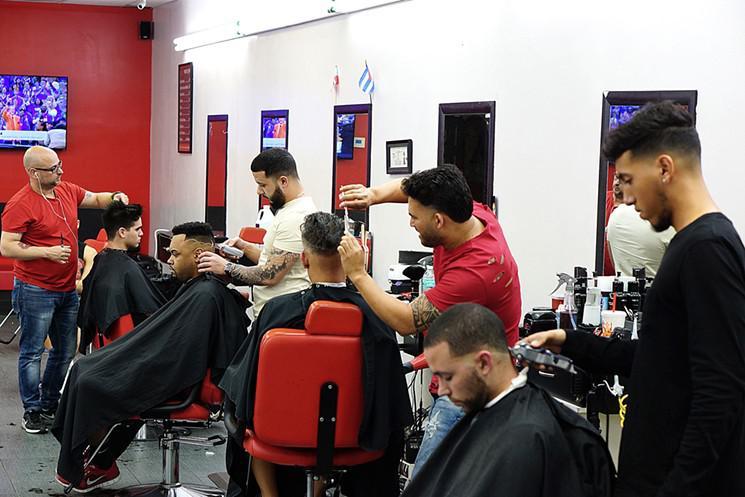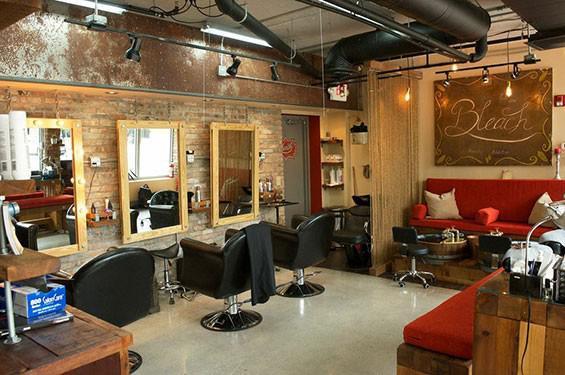The first image is the image on the left, the second image is the image on the right. Examine the images to the left and right. Is the description "In at least one image there are at least three men with black hair getting there hair cut." accurate? Answer yes or no. Yes. The first image is the image on the left, the second image is the image on the right. For the images displayed, is the sentence "The left image features a row of male customers sitting and wearing black smocks, with someone standing behind them." factually correct? Answer yes or no. Yes. 